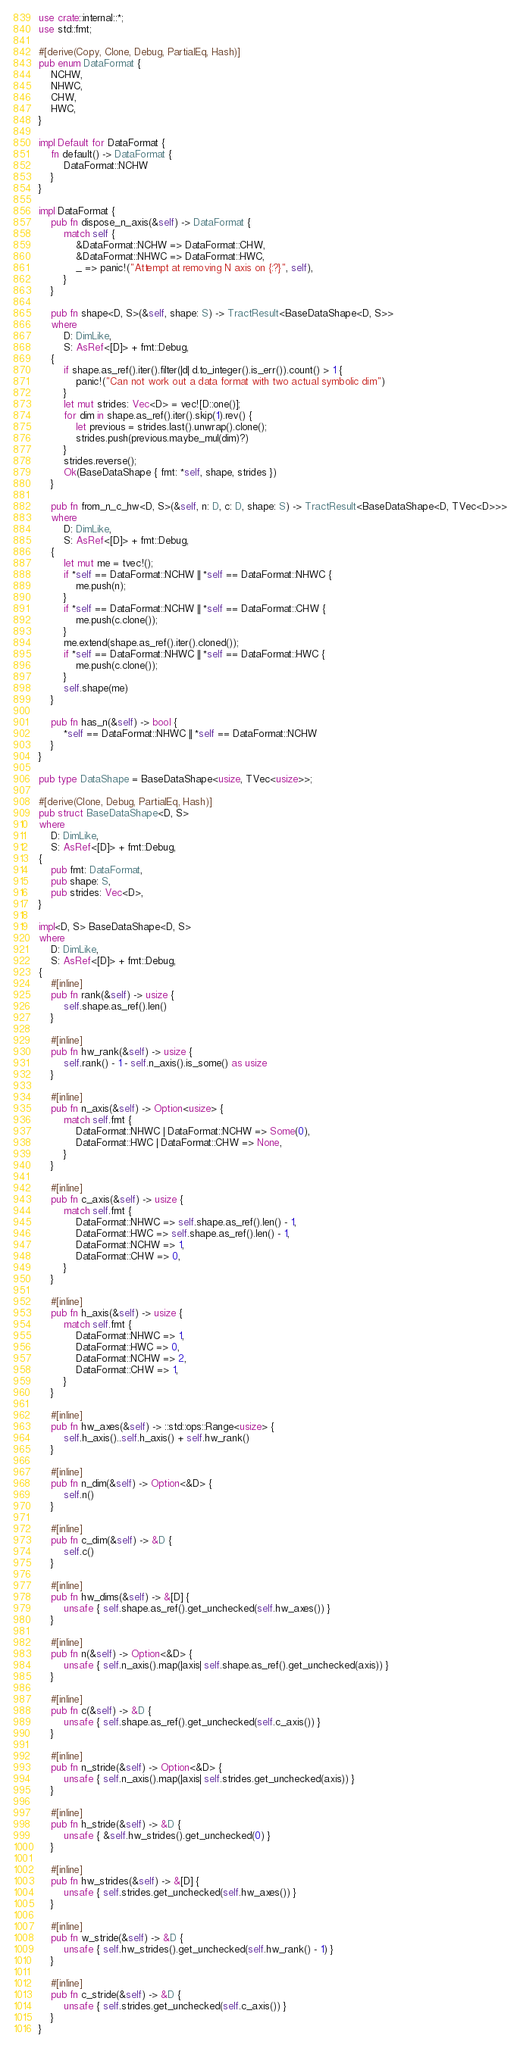Convert code to text. <code><loc_0><loc_0><loc_500><loc_500><_Rust_>use crate::internal::*;
use std::fmt;

#[derive(Copy, Clone, Debug, PartialEq, Hash)]
pub enum DataFormat {
    NCHW,
    NHWC,
    CHW,
    HWC,
}

impl Default for DataFormat {
    fn default() -> DataFormat {
        DataFormat::NCHW
    }
}

impl DataFormat {
    pub fn dispose_n_axis(&self) -> DataFormat {
        match self {
            &DataFormat::NCHW => DataFormat::CHW,
            &DataFormat::NHWC => DataFormat::HWC,
            _ => panic!("Attempt at removing N axis on {:?}", self),
        }
    }

    pub fn shape<D, S>(&self, shape: S) -> TractResult<BaseDataShape<D, S>>
    where
        D: DimLike,
        S: AsRef<[D]> + fmt::Debug,
    {
        if shape.as_ref().iter().filter(|d| d.to_integer().is_err()).count() > 1 {
            panic!("Can not work out a data format with two actual symbolic dim")
        }
        let mut strides: Vec<D> = vec![D::one()];
        for dim in shape.as_ref().iter().skip(1).rev() {
            let previous = strides.last().unwrap().clone();
            strides.push(previous.maybe_mul(dim)?)
        }
        strides.reverse();
        Ok(BaseDataShape { fmt: *self, shape, strides })
    }

    pub fn from_n_c_hw<D, S>(&self, n: D, c: D, shape: S) -> TractResult<BaseDataShape<D, TVec<D>>>
    where
        D: DimLike,
        S: AsRef<[D]> + fmt::Debug,
    {
        let mut me = tvec!();
        if *self == DataFormat::NCHW || *self == DataFormat::NHWC {
            me.push(n);
        }
        if *self == DataFormat::NCHW || *self == DataFormat::CHW {
            me.push(c.clone());
        }
        me.extend(shape.as_ref().iter().cloned());
        if *self == DataFormat::NHWC || *self == DataFormat::HWC {
            me.push(c.clone());
        }
        self.shape(me)
    }

    pub fn has_n(&self) -> bool {
        *self == DataFormat::NHWC || *self == DataFormat::NCHW
    }
}

pub type DataShape = BaseDataShape<usize, TVec<usize>>;

#[derive(Clone, Debug, PartialEq, Hash)]
pub struct BaseDataShape<D, S>
where
    D: DimLike,
    S: AsRef<[D]> + fmt::Debug,
{
    pub fmt: DataFormat,
    pub shape: S,
    pub strides: Vec<D>,
}

impl<D, S> BaseDataShape<D, S>
where
    D: DimLike,
    S: AsRef<[D]> + fmt::Debug,
{
    #[inline]
    pub fn rank(&self) -> usize {
        self.shape.as_ref().len()
    }

    #[inline]
    pub fn hw_rank(&self) -> usize {
        self.rank() - 1 - self.n_axis().is_some() as usize
    }

    #[inline]
    pub fn n_axis(&self) -> Option<usize> {
        match self.fmt {
            DataFormat::NHWC | DataFormat::NCHW => Some(0),
            DataFormat::HWC | DataFormat::CHW => None,
        }
    }

    #[inline]
    pub fn c_axis(&self) -> usize {
        match self.fmt {
            DataFormat::NHWC => self.shape.as_ref().len() - 1,
            DataFormat::HWC => self.shape.as_ref().len() - 1,
            DataFormat::NCHW => 1,
            DataFormat::CHW => 0,
        }
    }

    #[inline]
    pub fn h_axis(&self) -> usize {
        match self.fmt {
            DataFormat::NHWC => 1,
            DataFormat::HWC => 0,
            DataFormat::NCHW => 2,
            DataFormat::CHW => 1,
        }
    }

    #[inline]
    pub fn hw_axes(&self) -> ::std::ops::Range<usize> {
        self.h_axis()..self.h_axis() + self.hw_rank()
    }

    #[inline]
    pub fn n_dim(&self) -> Option<&D> {
        self.n()
    }

    #[inline]
    pub fn c_dim(&self) -> &D {
        self.c()
    }

    #[inline]
    pub fn hw_dims(&self) -> &[D] {
        unsafe { self.shape.as_ref().get_unchecked(self.hw_axes()) }
    }

    #[inline]
    pub fn n(&self) -> Option<&D> {
        unsafe { self.n_axis().map(|axis| self.shape.as_ref().get_unchecked(axis)) }
    }

    #[inline]
    pub fn c(&self) -> &D {
        unsafe { self.shape.as_ref().get_unchecked(self.c_axis()) }
    }

    #[inline]
    pub fn n_stride(&self) -> Option<&D> {
        unsafe { self.n_axis().map(|axis| self.strides.get_unchecked(axis)) }
    }

    #[inline]
    pub fn h_stride(&self) -> &D {
        unsafe { &self.hw_strides().get_unchecked(0) }
    }

    #[inline]
    pub fn hw_strides(&self) -> &[D] {
        unsafe { self.strides.get_unchecked(self.hw_axes()) }
    }

    #[inline]
    pub fn w_stride(&self) -> &D {
        unsafe { self.hw_strides().get_unchecked(self.hw_rank() - 1) }
    }

    #[inline]
    pub fn c_stride(&self) -> &D {
        unsafe { self.strides.get_unchecked(self.c_axis()) }
    }
}
</code> 